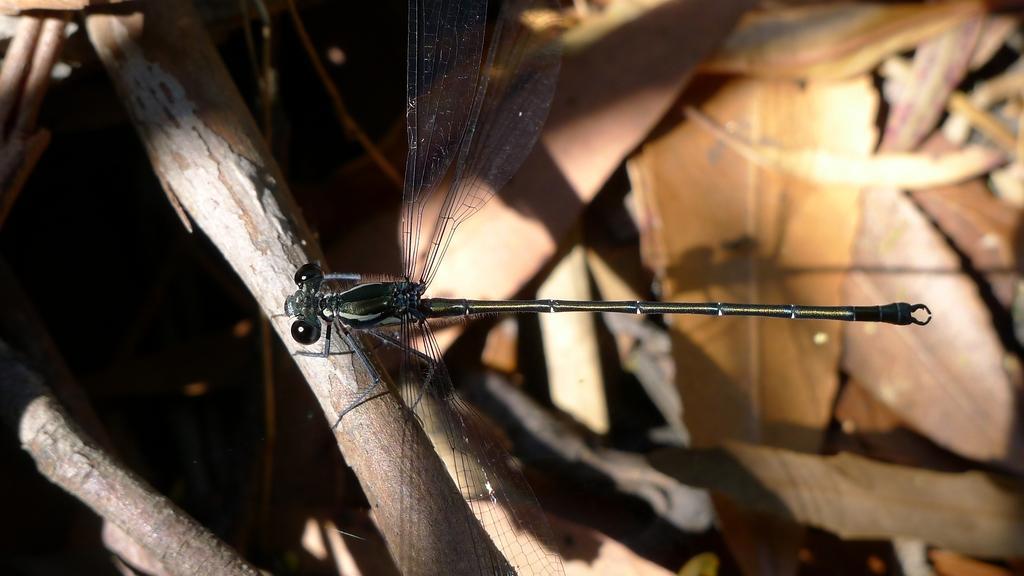In one or two sentences, can you explain what this image depicts? In this picture we can see a insect and there are leaves. 